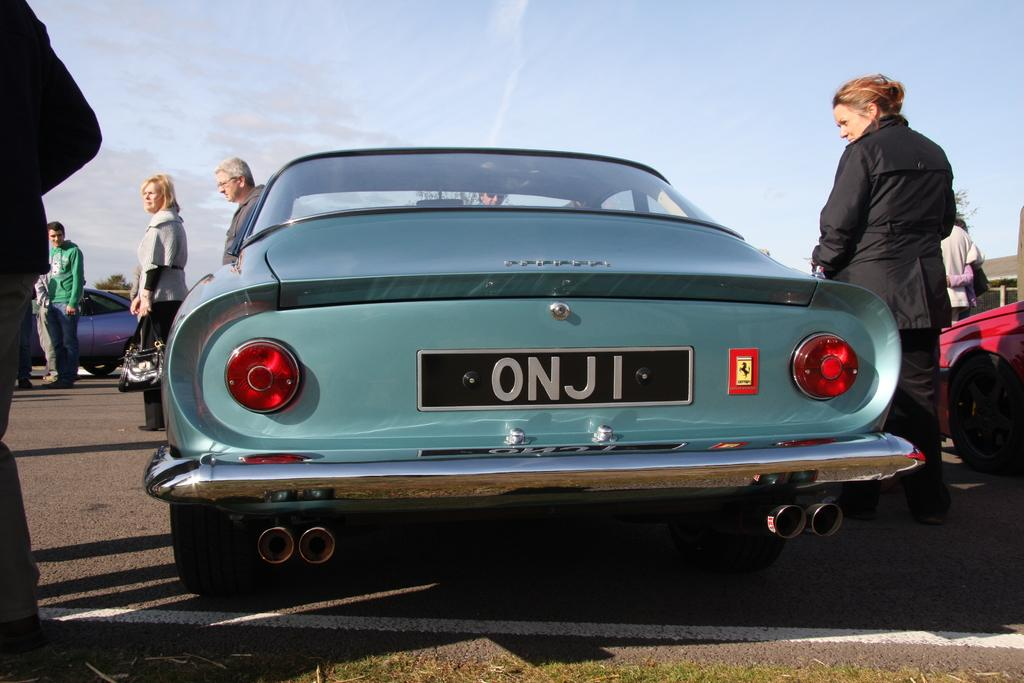What can be seen on the road in the image? There are cars parked on the road in the image. What are the people near the cars doing? There are people standing beside the cars in the image. What can be seen in the distance in the image? There is a building visible in the background of the image. How would you describe the weather in the image? The sky is clear in the image, suggesting good weather. Can you tell me how many pickles are on the roof of the building in the image? There are no pickles visible on the roof of the building in the image. What type of rod is being used by the people standing beside the cars? There is no rod present in the image; the people are simply standing beside the cars. 